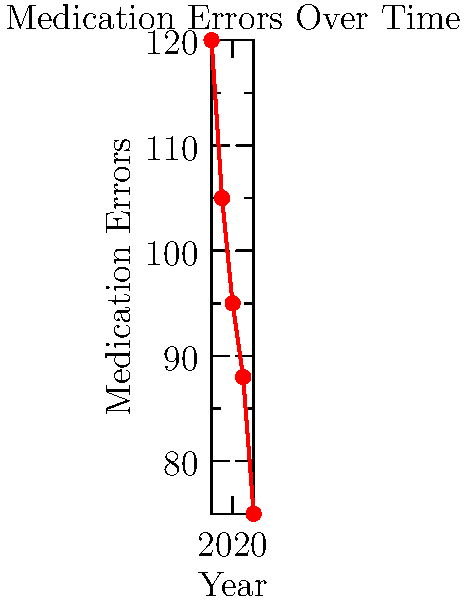Based on the line graph showing medication errors from 2018 to 2022, calculate the average annual reduction in errors. If this trend continues, in which year would medication errors be expected to reach zero? To solve this question, we need to follow these steps:

1. Calculate the total reduction in errors from 2018 to 2022:
   Initial errors (2018): 120
   Final errors (2022): 75
   Total reduction = 120 - 75 = 45 errors

2. Calculate the average annual reduction:
   Number of years = 5 (2018 to 2022, inclusive)
   Average annual reduction = 45 / 4 = 11.25 errors per year

3. Determine how many more years it would take to reach zero errors:
   Current errors (2022): 75
   Years to zero = 75 / 11.25 ≈ 6.67 years

4. Add this to the last year in the dataset:
   2022 + 6.67 ≈ 2028.67

5. Round up to the next full year:
   Expected year to reach zero errors: 2029

This calculation assumes the trend continues linearly, which may not be realistic in practice as it becomes increasingly difficult to eliminate the last few errors.
Answer: 2029 